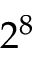Convert formula to latex. <formula><loc_0><loc_0><loc_500><loc_500>2 ^ { 8 }</formula> 